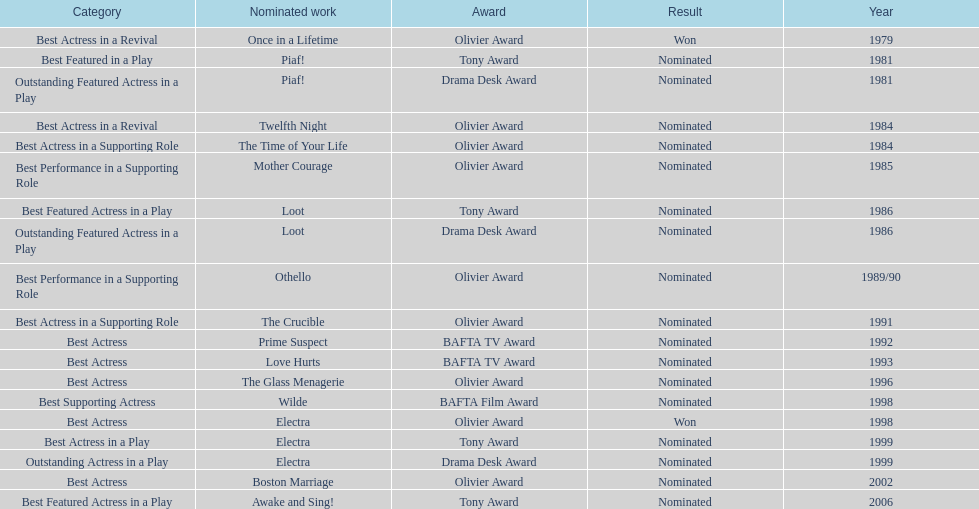What award did once in a lifetime win? Best Actress in a Revival. 